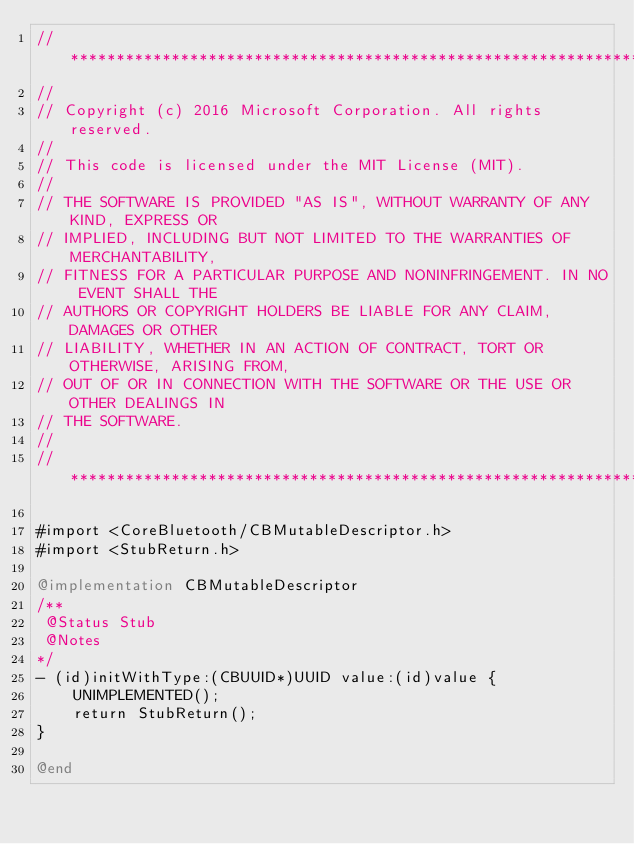<code> <loc_0><loc_0><loc_500><loc_500><_ObjectiveC_>//******************************************************************************
//
// Copyright (c) 2016 Microsoft Corporation. All rights reserved.
//
// This code is licensed under the MIT License (MIT).
//
// THE SOFTWARE IS PROVIDED "AS IS", WITHOUT WARRANTY OF ANY KIND, EXPRESS OR
// IMPLIED, INCLUDING BUT NOT LIMITED TO THE WARRANTIES OF MERCHANTABILITY,
// FITNESS FOR A PARTICULAR PURPOSE AND NONINFRINGEMENT. IN NO EVENT SHALL THE
// AUTHORS OR COPYRIGHT HOLDERS BE LIABLE FOR ANY CLAIM, DAMAGES OR OTHER
// LIABILITY, WHETHER IN AN ACTION OF CONTRACT, TORT OR OTHERWISE, ARISING FROM,
// OUT OF OR IN CONNECTION WITH THE SOFTWARE OR THE USE OR OTHER DEALINGS IN
// THE SOFTWARE.
//
//******************************************************************************

#import <CoreBluetooth/CBMutableDescriptor.h>
#import <StubReturn.h>

@implementation CBMutableDescriptor
/**
 @Status Stub
 @Notes
*/
- (id)initWithType:(CBUUID*)UUID value:(id)value {
    UNIMPLEMENTED();
    return StubReturn();
}

@end
</code> 